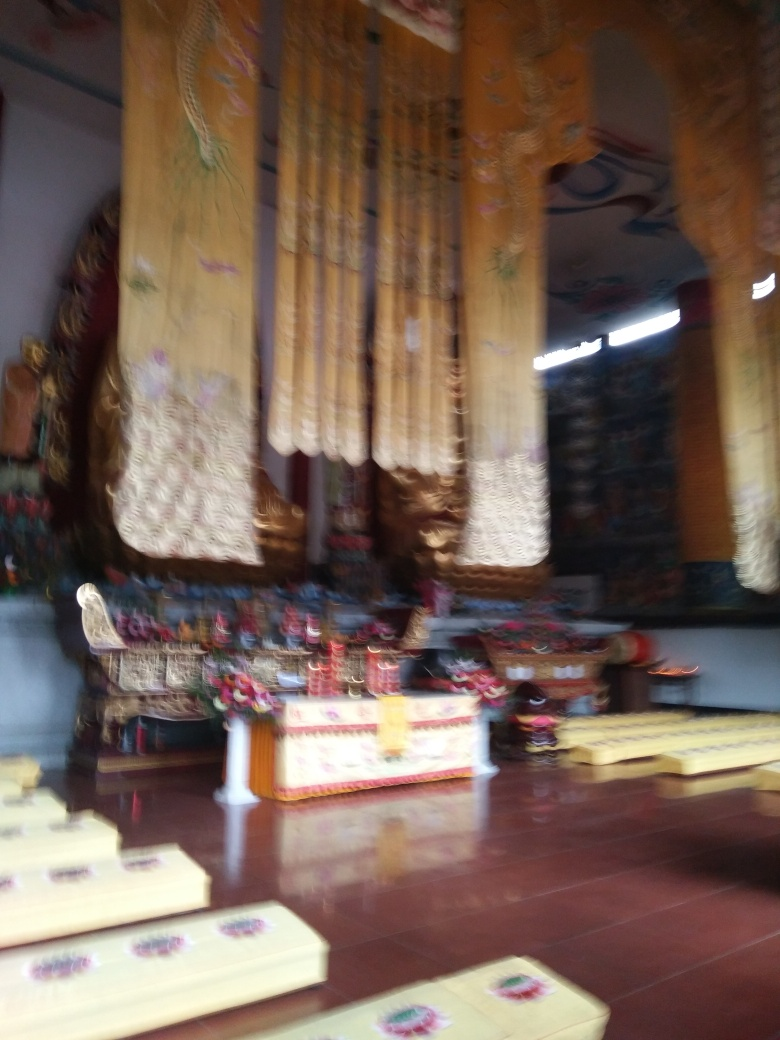Is this photograph taken during an ongoing event? It's hard to say for sure since the photograph is blurred and there are no clear indications of people or activities. However, the absence of people in the visible area suggests that it might have been taken before or after an event, or during a quiet moment. 